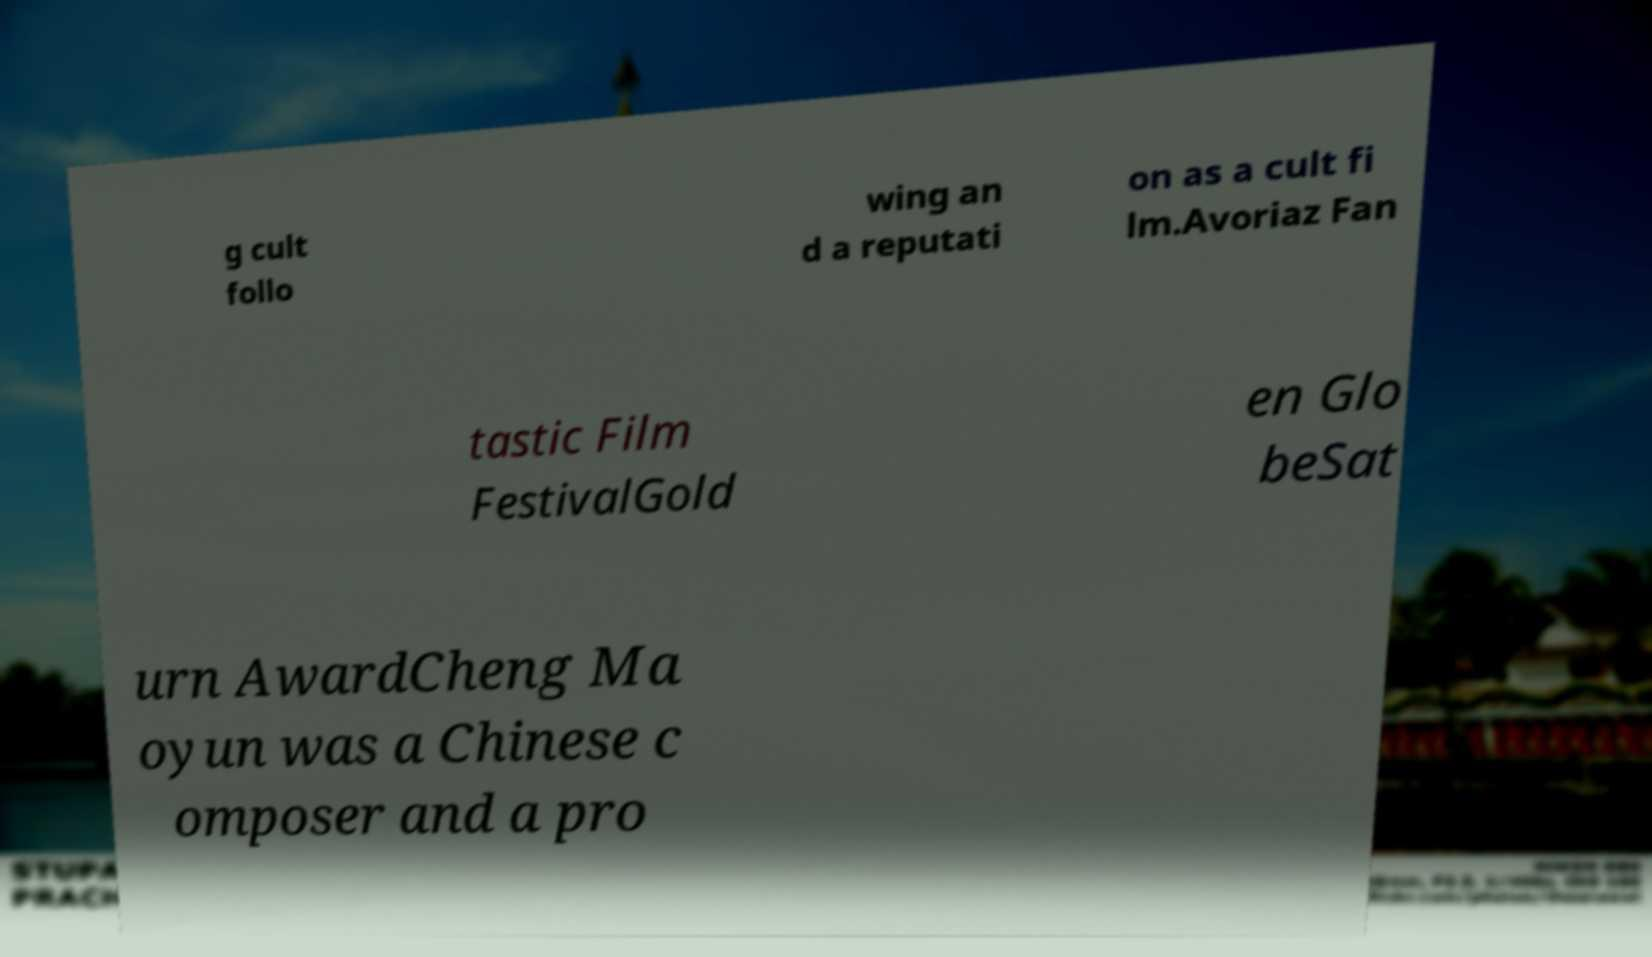Please identify and transcribe the text found in this image. g cult follo wing an d a reputati on as a cult fi lm.Avoriaz Fan tastic Film FestivalGold en Glo beSat urn AwardCheng Ma oyun was a Chinese c omposer and a pro 